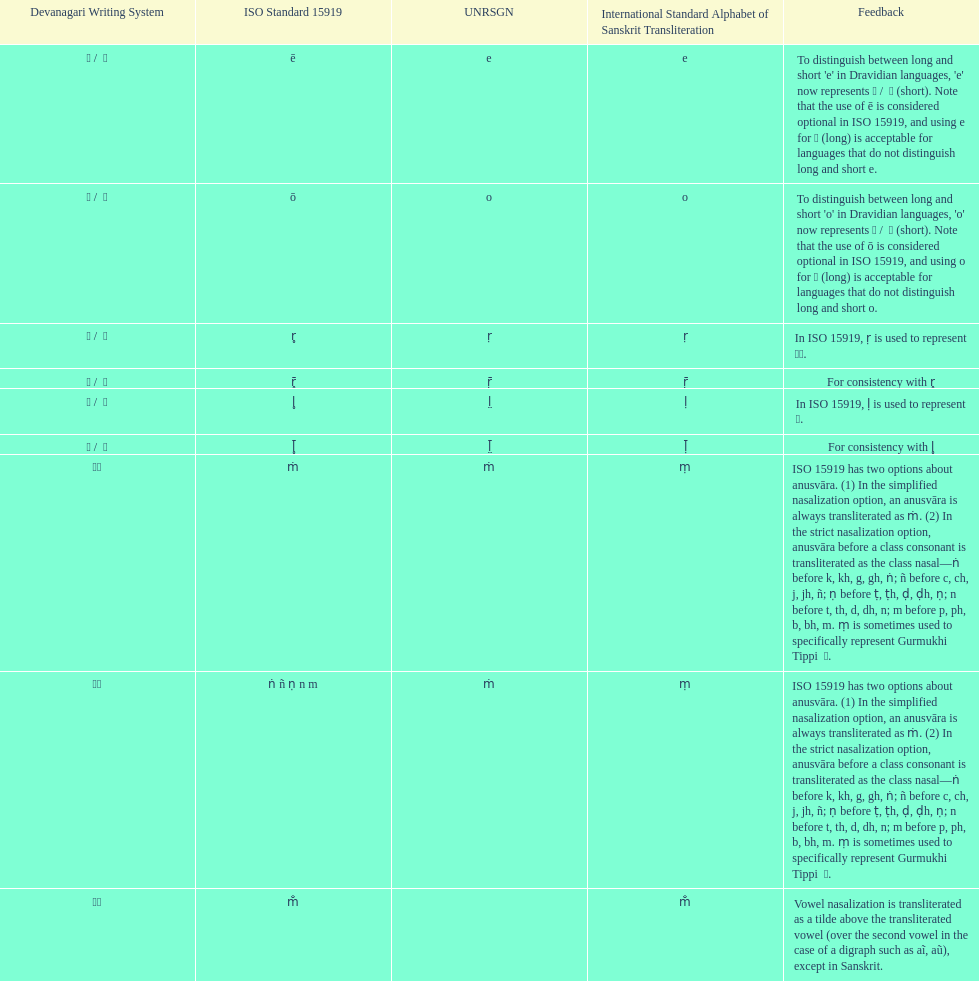What unrsgn is listed previous to the o? E. 